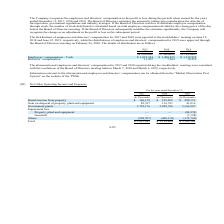According to United Micro Electronics's financial document, How does the the Board of Directors estimates the compensation amount? The Board of Directors estimates the amount by taking into consideration the Articles of Incorporation, government regulations and industry averages.. The document states: "the years ended December 31, 2017, 2018 and 2019. The Board of Directors estimates the amount by taking into consideration the Articles of Incorporati..." Also, When was the distributions of employees and directors’ compensation for 2017 and 2018 reported? The document shows two values: June 12, 2018 and June 12, 2019. From the document: "to the stockholders’ meeting on June 12, 2018 and June 12, 2019, respectively, while the distributions of employees and directors’ compensation for 20..." Also, Where can the Information relevant to the aforementioned employees and directors’ compensation be obtained? “Market Observation Post System” on the website of the TWSE. The document states: "d directors’ compensation can be obtained from the “Market Observation Post System” on the website of the TWSE...." Also, can you calculate: What is the average Directors’ compensation? To answer this question, I need to perform calculations using the financial data. The calculation is: (11,452+7,624+10,259) / 3, which equals 9778.33 (in thousands). This is based on the information: "00,835 $ 1,132,952 Directors’ compensation 11,452 7,624 10,259 $ 1,132,952 Directors’ compensation 11,452 7,624 10,259 4 $ 1,400,835 $ 1,132,952 Directors’ compensation 11,452 7,624 10,259..." The key data points involved are: 10,259, 11,452, 7,624. Also, can you calculate: What is the increase/ (decrease) in Directors’ compensation from 2018 to 2019? Based on the calculation: 10,259-7,624, the result is 2635 (in thousands). This is based on the information: "00,835 $ 1,132,952 Directors’ compensation 11,452 7,624 10,259 $ 1,132,952 Directors’ compensation 11,452 7,624 10,259..." The key data points involved are: 10,259, 7,624. Also, can you calculate: What is the increase/ (decrease) in Employees’ compensation – Cash from 2018 to 2019? Based on the calculation: 1,132,952-1,400,835, the result is -267883 (in thousands). This is based on the information: "es’ compensation – Cash $ 1,032,324 $ 1,400,835 $ 1,132,952 Directors’ compensation 11,452 7,624 10,259 nds) Employees’ compensation – Cash $ 1,032,324 $ 1,400,835 $ 1,132,952 Directors’ compensation ..." The key data points involved are: 1,132,952, 1,400,835. 